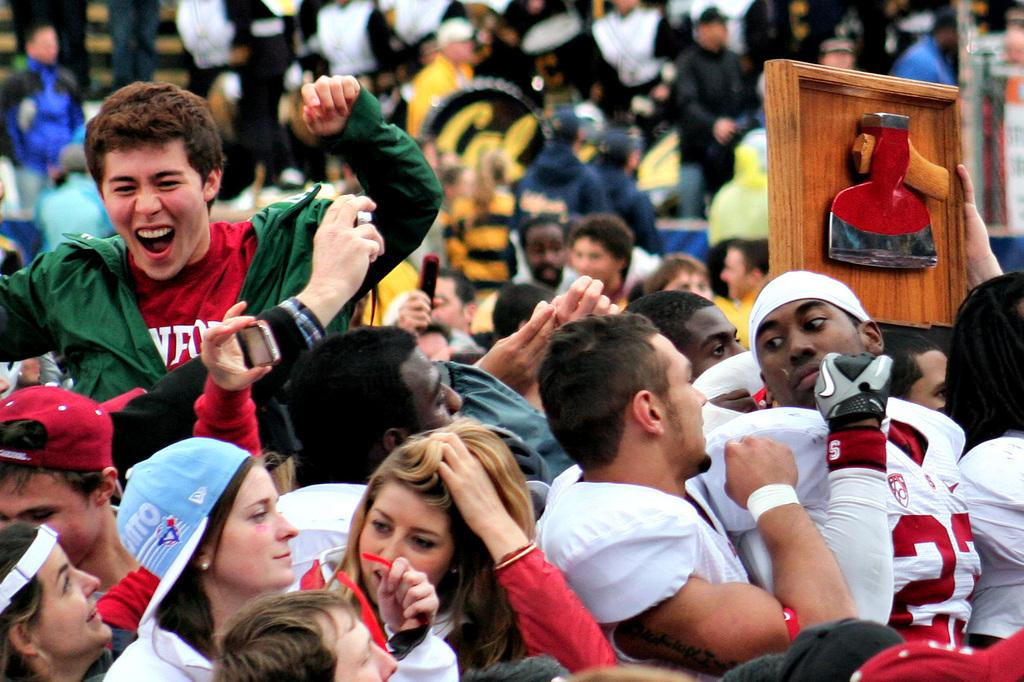How many people are in the image? There are people in the image, but the exact number is not specified. What are some people doing in the image? Some people are holding objects in the image. Can you describe the wooden object in the image? There is a wooden object in the image, but its specific characteristics are not mentioned. What type of winter comfort can be seen in the image? There is no mention of winter, comfort, or waves in the image. 